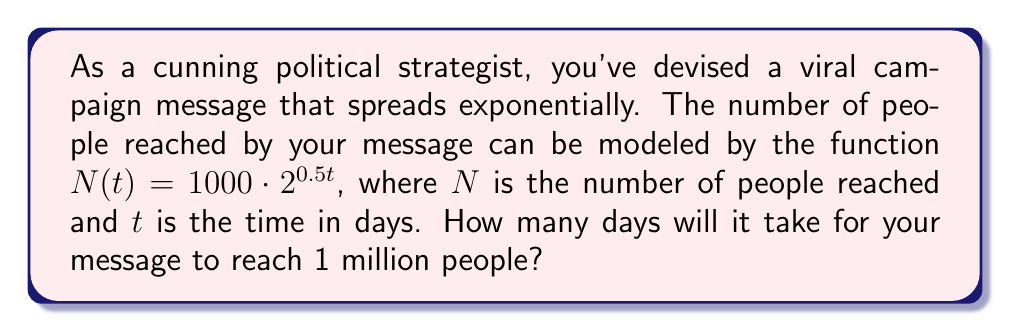Could you help me with this problem? To solve this problem, we need to use logarithms. Let's approach this step-by-step:

1) We want to find $t$ when $N(t) = 1,000,000$. So, we set up the equation:

   $1,000,000 = 1000 \cdot 2^{0.5t}$

2) First, let's divide both sides by 1000:

   $1,000 = 2^{0.5t}$

3) Now, we can take the logarithm (base 2) of both sides:

   $\log_2(1,000) = \log_2(2^{0.5t})$

4) Using the logarithm property $\log_a(a^x) = x$, we can simplify the right side:

   $\log_2(1,000) = 0.5t$

5) Now, let's solve for $t$:

   $t = \frac{\log_2(1,000)}{0.5}$

6) We can calculate this:
   
   $\log_2(1,000) \approx 9.97$
   
   $t = \frac{9.97}{0.5} \approx 19.93$

7) Since we're dealing with days, we need to round up to the nearest whole number.
Answer: It will take 20 days for the campaign message to reach 1 million people. 